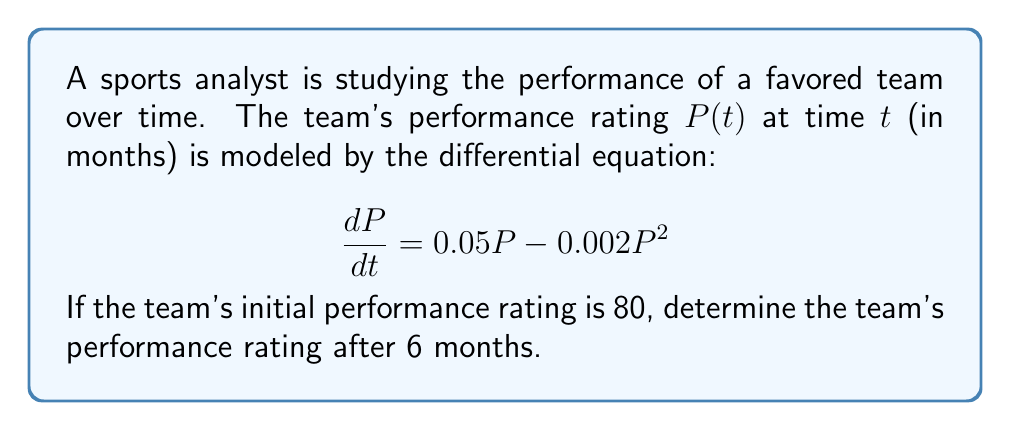Can you solve this math problem? To solve this problem, we need to use the method for solving first-order differential equations, specifically the separation of variables technique.

1) First, let's separate the variables:

   $$ \frac{dP}{0.05P - 0.002P^2} = dt $$

2) Integrate both sides:

   $$ \int \frac{dP}{0.05P - 0.002P^2} = \int dt $$

3) The left side can be integrated using partial fractions:

   $$ \int \frac{dP}{P(0.05 - 0.002P)} = \int dt $$

   Let $u = 0.05 - 0.002P$, then $du = -0.002dP$

   $$ -500 \int \frac{du}{u(25-u)} = t + C $$

4) This integrates to:

   $$ 20\ln|u| - 20\ln|25-u| = t + C $$

5) Substituting back $u = 0.05 - 0.002P$:

   $$ 20\ln|0.05 - 0.002P| - 20\ln|25-(0.05 - 0.002P)| = t + C $$

6) Using the initial condition $P(0) = 80$:

   $$ 20\ln|0.05 - 0.002(80)| - 20\ln|25-(0.05 - 0.002(80))| = 0 + C $$
   $$ 20\ln|-0.11| - 20\ln|24.89| = C $$

7) Now we can write the general solution:

   $$ 20\ln|0.05 - 0.002P| - 20\ln|25-(0.05 - 0.002P)| - 20\ln|-0.11| + 20\ln|24.89| = t $$

8) To find $P(6)$, we substitute $t=6$ and solve for $P$:

   $$ 20\ln|0.05 - 0.002P| - 20\ln|25-(0.05 - 0.002P)| - 20\ln|-0.11| + 20\ln|24.89| = 6 $$

9) This equation can be solved numerically to get $P \approx 94.74$.
Answer: The team's performance rating after 6 months is approximately 94.74. 